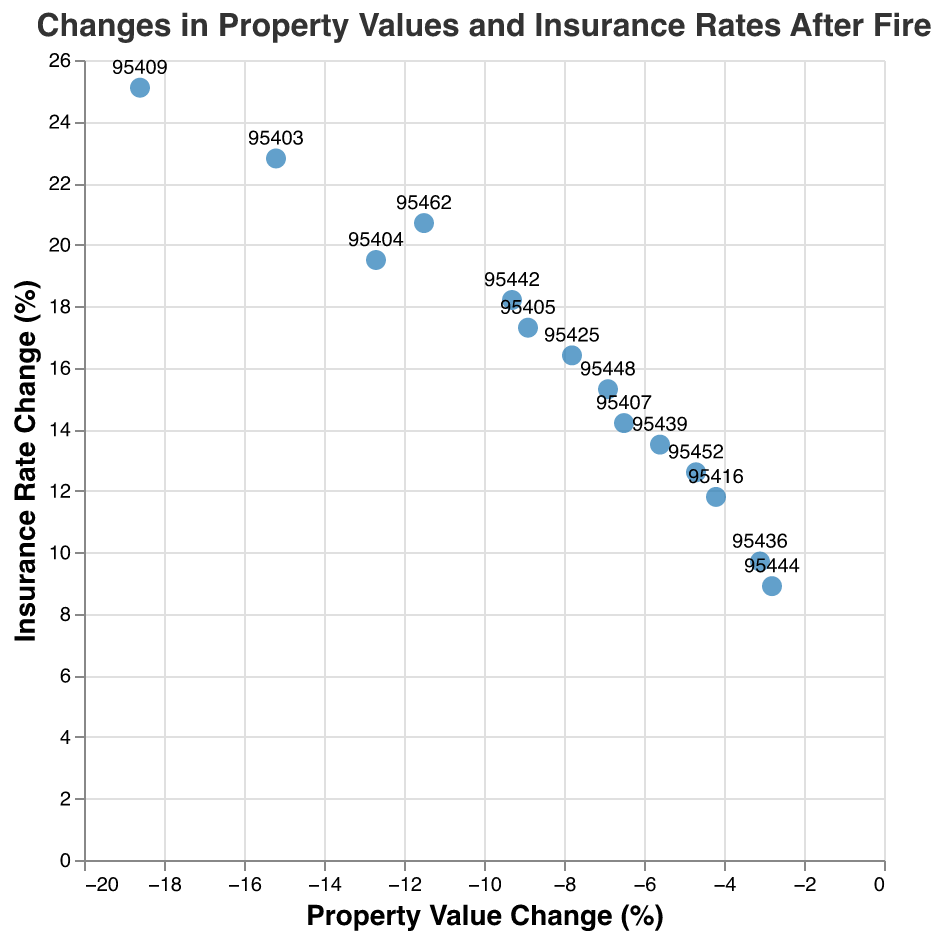What is the title of the figure? The title is located at the top of the figure and it is a summary of what the figure is representing.
Answer: Changes in Property Values and Insurance Rates After Fire What does the x-axis represent? The x-axis represents the changes in property values (%) for each zip code after the fire. This information is listed horizontally along the bottom of the plot.
Answer: Property Value Change (%) Which zip code shows the largest decrease in property values? Scan the x-axis values and find the most negative value. Check the corresponding zip code associated with this point.
Answer: 95409 How many zip codes experienced a decrease of over 10% in property values? Identify the points where the x-axis value (Property Value Change) is less than -10% and count them.
Answer: 4 Which zip code had the highest increase in insurance rates? Look for the highest value along the y-axis (Insurance Rate Change) and find the associated zip code.
Answer: 95409 Which zip code had the smallest increase in insurance rates? Look for the smallest value along the y-axis (Insurance Rate Change) and find the associated zip code.
Answer: 95444 Is there a correlation between property value changes and insurance rate changes? Look at the general trend of the points plotted. If most points follow a clear upward or downward trend, there is a correlation.
Answer: Yes, there is a positive correlation Compare the property value changes of zip code 95404 and 95462. Which one had a larger decrease? Find the points for zip codes 95404 and 95462, then compare their x-axis values (Property Value Change). The one with the more negative value had a larger decrease.
Answer: 95404 What is the average increase in insurance rates for the zip codes listed? Add up all the Insurance Rate Change (%) values and divide by the number of zip codes.
Answer: (22.8 + 19.5 + 17.3 + 14.2 + 25.1 + 11.8 + 16.4 + 9.7 + 13.5 + 18.2 + 8.9 + 15.3 + 12.6 + 20.7) / 14 = 16.1% Which zip code shows the smallest decrease in property values? Identify the point on the plot with the x-axis value closest to zero but still negative and find the corresponding zip code.
Answer: 95444 